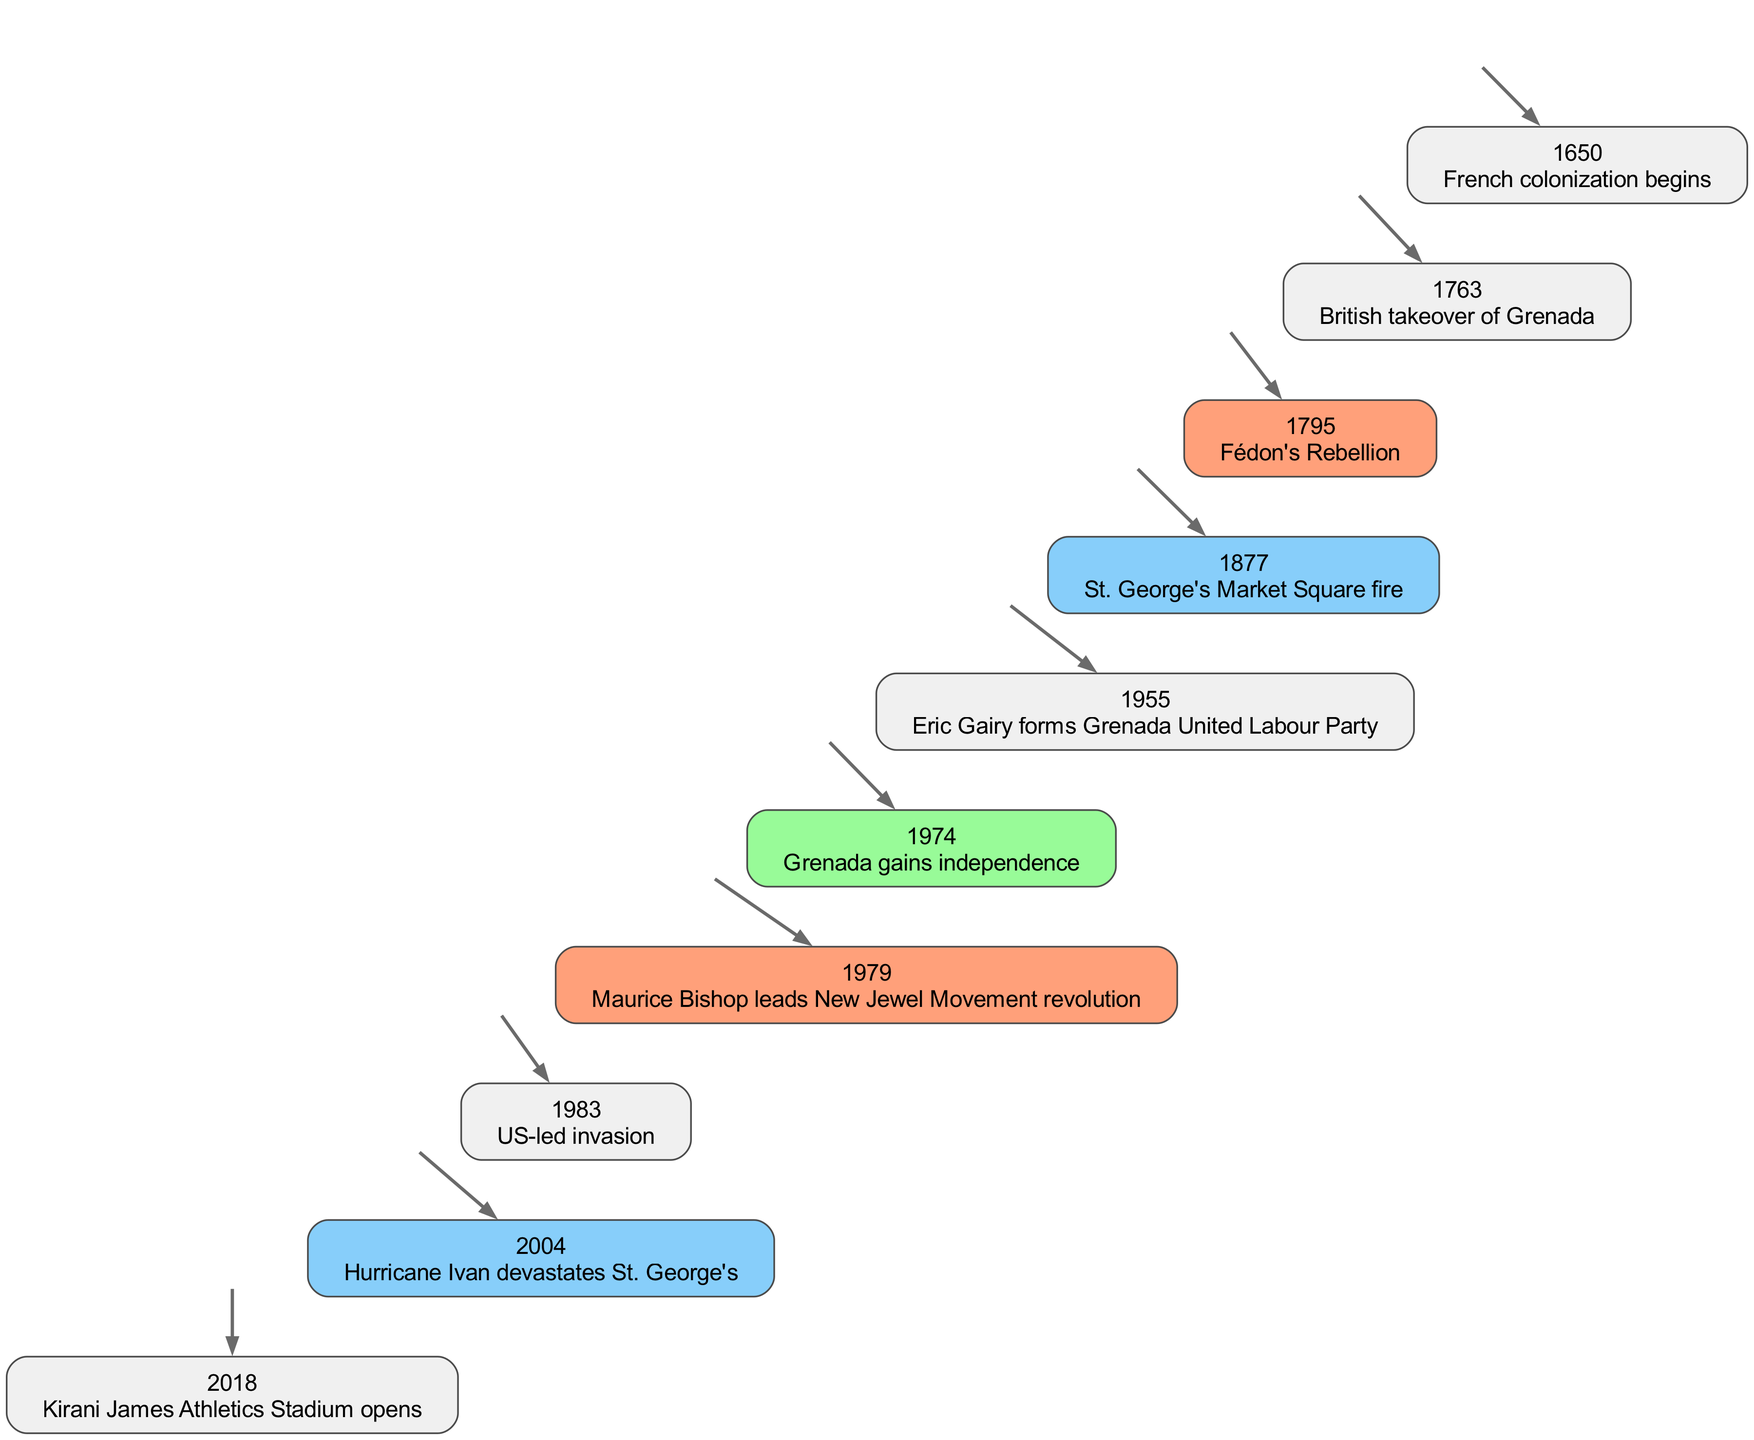What year did the British takeover of Grenada occur? The timeline indicates that the British takeover of Grenada happened in 1763, as this event is listed explicitly with its corresponding year.
Answer: 1763 How many significant events are listed in the timeline? By counting the events in the timeline data, we see there are a total of 10 events.
Answer: 10 What is the event that corresponds to the year 1983? Referring to the timeline, the event listed for the year 1983 is the US-led invasion, which can be directly found in the data provided.
Answer: US-led invasion What color represents events related to disasters in the timeline? The timeline indicates that light sky blue is the color used to represent events related to disasters, evident from the color coding of the nodes in the diagram.
Answer: Light Sky Blue What terminal event follows Grenada gaining independence in 1974? The timeline shows that after the event of Grenada gaining independence in 1974, the next event is the revolution led by Maurice Bishop in 1979, which can be tracked along the timeline flow.
Answer: Maurice Bishop leads New Jewel Movement revolution Which event marks the beginning of French colonization? According to the timeline data, the event that marks the beginning of French colonization is listed as occurring in 1650.
Answer: French colonization begins Identify the first major political event in the timeline. The first event that can be categorized as a major political change is the British takeover of Grenada in 1763, as it represents a significant shift in governance on the island.
Answer: British takeover of Grenada What major cultural milestone occurred in 2018? The timeline states that the Kirani James Athletics Stadium opened in 2018, marking a significant cultural development in St. George's history.
Answer: Kirani James Athletics Stadium opens What significant rebellion occurred in 1795? From the timeline, it is evident that Fédon's Rebellion is the significant event that happened in 1795, directly referenced in the data.
Answer: Fédon's Rebellion Which event is associated with the year 2004? The event associated with the year 2004 is Hurricane Ivan, as highlighted in the timeline data, indicating its impact on St. George's.
Answer: Hurricane Ivan devastates St. George's 